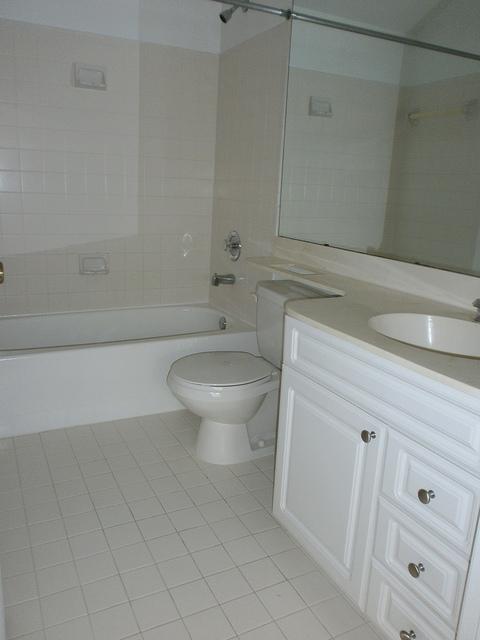Is there a picture on the bathroom wall?
Keep it brief. No. Is there a window?
Concise answer only. No. Is there any color in this room?
Answer briefly. No. Is the bedroom a part of the bathroom?
Concise answer only. No. What room is this?
Be succinct. Bathroom. What is reflected in the mirror?
Answer briefly. Shower. What type of room is this?
Concise answer only. Bathroom. How many cats do you see?
Write a very short answer. 0. Is there a cactus by the sink?
Give a very brief answer. No. How many diamond shapes are here?
Keep it brief. 0. What would be used to keep water from spilling out of the shower area?
Answer briefly. Shower curtain. Do the floors appear to be made of wood?
Be succinct. No. How many shelf handles are in this picture?
Answer briefly. 4. Is the room dirty?
Answer briefly. No. Does this bathroom need to be renovated?
Keep it brief. No. What type of cabinet is this?
Be succinct. Bathroom. What room is depicted?
Short answer required. Bathroom. How many towels are hanging on the towel rack?
Keep it brief. 0. How many sinks are in this image?
Concise answer only. 1. Is this a bathroom?
Answer briefly. Yes. Is this a public bathroom?
Quick response, please. No. Who was supposed to be watching the dogs in this room?
Be succinct. No one. Are these typical American sinks?
Concise answer only. Yes. 